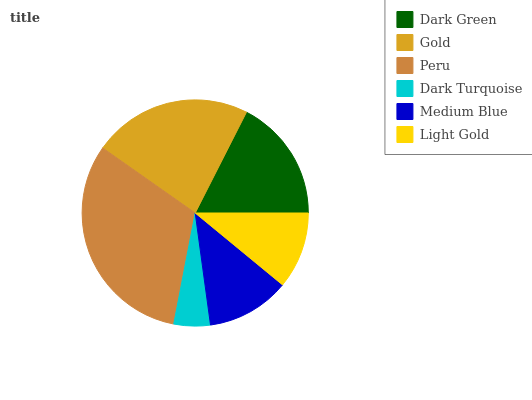Is Dark Turquoise the minimum?
Answer yes or no. Yes. Is Peru the maximum?
Answer yes or no. Yes. Is Gold the minimum?
Answer yes or no. No. Is Gold the maximum?
Answer yes or no. No. Is Gold greater than Dark Green?
Answer yes or no. Yes. Is Dark Green less than Gold?
Answer yes or no. Yes. Is Dark Green greater than Gold?
Answer yes or no. No. Is Gold less than Dark Green?
Answer yes or no. No. Is Dark Green the high median?
Answer yes or no. Yes. Is Medium Blue the low median?
Answer yes or no. Yes. Is Medium Blue the high median?
Answer yes or no. No. Is Dark Green the low median?
Answer yes or no. No. 